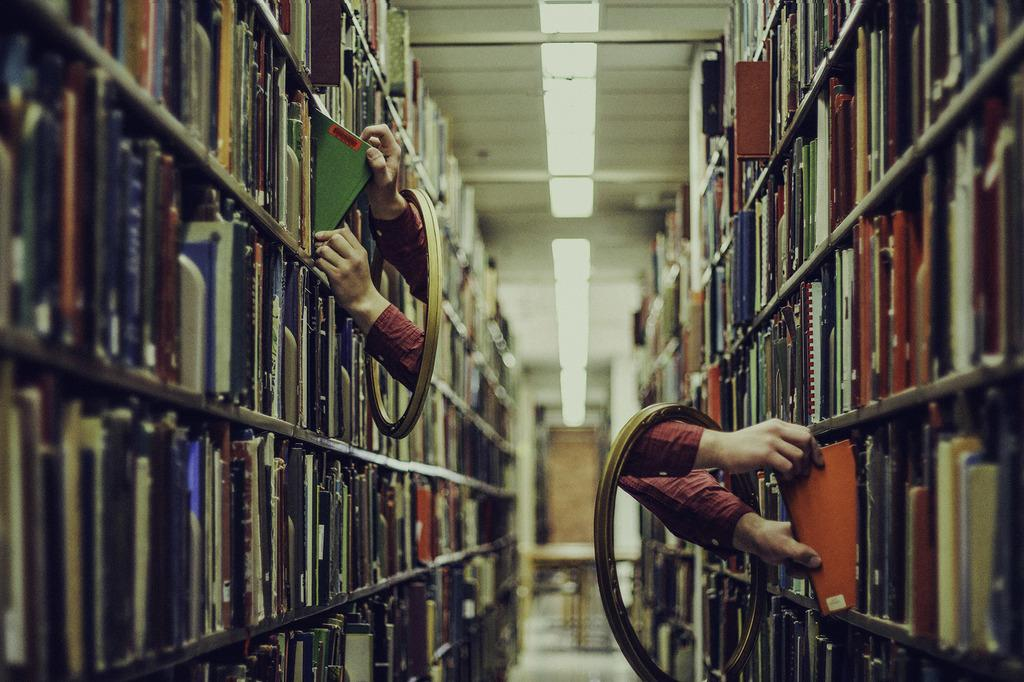What type of objects can be seen on the shelves in the image? There are books in the shelves in the image. Can you describe any other details about the image? A person's hands are visible in the image. What type of juice is being poured from the drum in the image? There is no juice or drum present in the image. What songs are being sung by the person in the image? There is no indication of singing or songs in the image, as it only shows books on shelves and a person's hands. 